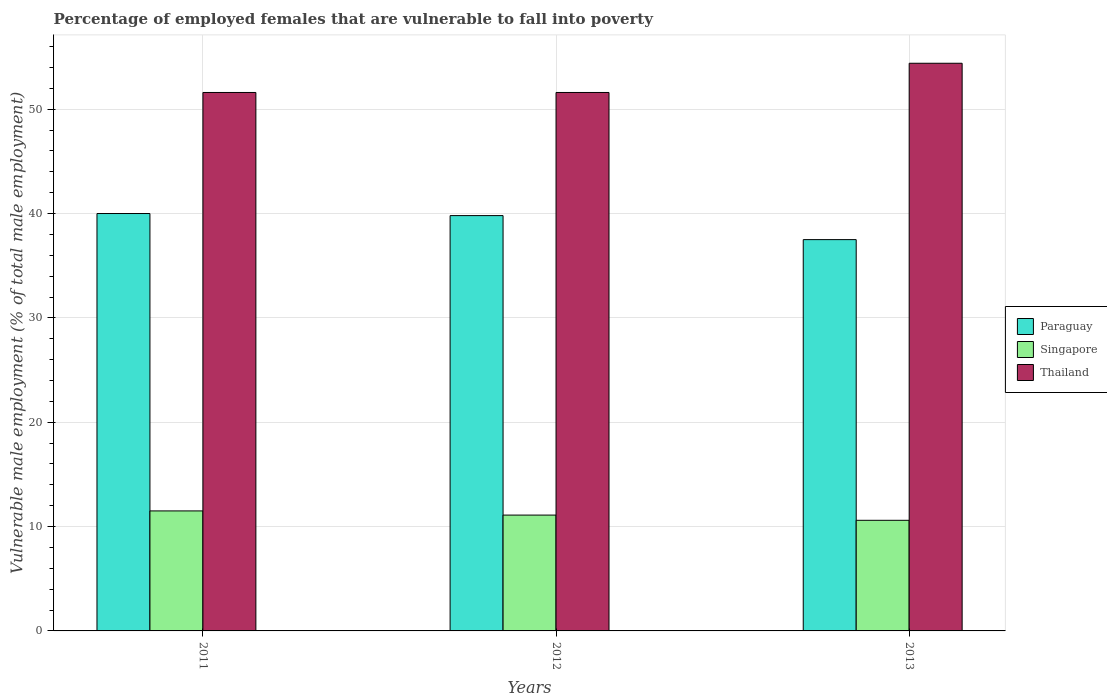How many different coloured bars are there?
Keep it short and to the point. 3. How many bars are there on the 1st tick from the left?
Provide a succinct answer. 3. How many bars are there on the 1st tick from the right?
Keep it short and to the point. 3. In how many cases, is the number of bars for a given year not equal to the number of legend labels?
Give a very brief answer. 0. What is the percentage of employed females who are vulnerable to fall into poverty in Thailand in 2011?
Provide a succinct answer. 51.6. Across all years, what is the maximum percentage of employed females who are vulnerable to fall into poverty in Thailand?
Give a very brief answer. 54.4. Across all years, what is the minimum percentage of employed females who are vulnerable to fall into poverty in Singapore?
Make the answer very short. 10.6. In which year was the percentage of employed females who are vulnerable to fall into poverty in Singapore maximum?
Provide a short and direct response. 2011. What is the total percentage of employed females who are vulnerable to fall into poverty in Singapore in the graph?
Give a very brief answer. 33.2. What is the difference between the percentage of employed females who are vulnerable to fall into poverty in Paraguay in 2012 and that in 2013?
Your answer should be very brief. 2.3. What is the difference between the percentage of employed females who are vulnerable to fall into poverty in Paraguay in 2011 and the percentage of employed females who are vulnerable to fall into poverty in Singapore in 2013?
Your response must be concise. 29.4. What is the average percentage of employed females who are vulnerable to fall into poverty in Paraguay per year?
Keep it short and to the point. 39.1. In the year 2011, what is the difference between the percentage of employed females who are vulnerable to fall into poverty in Singapore and percentage of employed females who are vulnerable to fall into poverty in Thailand?
Offer a very short reply. -40.1. In how many years, is the percentage of employed females who are vulnerable to fall into poverty in Paraguay greater than 6 %?
Make the answer very short. 3. What is the ratio of the percentage of employed females who are vulnerable to fall into poverty in Thailand in 2011 to that in 2013?
Give a very brief answer. 0.95. What is the difference between the highest and the second highest percentage of employed females who are vulnerable to fall into poverty in Paraguay?
Your response must be concise. 0.2. Is the sum of the percentage of employed females who are vulnerable to fall into poverty in Thailand in 2011 and 2012 greater than the maximum percentage of employed females who are vulnerable to fall into poverty in Paraguay across all years?
Ensure brevity in your answer.  Yes. What does the 3rd bar from the left in 2011 represents?
Offer a terse response. Thailand. What does the 1st bar from the right in 2013 represents?
Your answer should be very brief. Thailand. Is it the case that in every year, the sum of the percentage of employed females who are vulnerable to fall into poverty in Paraguay and percentage of employed females who are vulnerable to fall into poverty in Thailand is greater than the percentage of employed females who are vulnerable to fall into poverty in Singapore?
Provide a short and direct response. Yes. Are all the bars in the graph horizontal?
Ensure brevity in your answer.  No. How many years are there in the graph?
Your answer should be very brief. 3. What is the difference between two consecutive major ticks on the Y-axis?
Keep it short and to the point. 10. Are the values on the major ticks of Y-axis written in scientific E-notation?
Keep it short and to the point. No. Does the graph contain grids?
Offer a terse response. Yes. What is the title of the graph?
Your answer should be compact. Percentage of employed females that are vulnerable to fall into poverty. What is the label or title of the X-axis?
Offer a very short reply. Years. What is the label or title of the Y-axis?
Your answer should be very brief. Vulnerable male employment (% of total male employment). What is the Vulnerable male employment (% of total male employment) of Paraguay in 2011?
Provide a short and direct response. 40. What is the Vulnerable male employment (% of total male employment) of Singapore in 2011?
Your response must be concise. 11.5. What is the Vulnerable male employment (% of total male employment) of Thailand in 2011?
Ensure brevity in your answer.  51.6. What is the Vulnerable male employment (% of total male employment) of Paraguay in 2012?
Your response must be concise. 39.8. What is the Vulnerable male employment (% of total male employment) of Singapore in 2012?
Offer a terse response. 11.1. What is the Vulnerable male employment (% of total male employment) in Thailand in 2012?
Provide a succinct answer. 51.6. What is the Vulnerable male employment (% of total male employment) in Paraguay in 2013?
Offer a terse response. 37.5. What is the Vulnerable male employment (% of total male employment) of Singapore in 2013?
Make the answer very short. 10.6. What is the Vulnerable male employment (% of total male employment) in Thailand in 2013?
Provide a short and direct response. 54.4. Across all years, what is the maximum Vulnerable male employment (% of total male employment) of Thailand?
Keep it short and to the point. 54.4. Across all years, what is the minimum Vulnerable male employment (% of total male employment) in Paraguay?
Give a very brief answer. 37.5. Across all years, what is the minimum Vulnerable male employment (% of total male employment) of Singapore?
Offer a terse response. 10.6. Across all years, what is the minimum Vulnerable male employment (% of total male employment) of Thailand?
Ensure brevity in your answer.  51.6. What is the total Vulnerable male employment (% of total male employment) in Paraguay in the graph?
Your response must be concise. 117.3. What is the total Vulnerable male employment (% of total male employment) in Singapore in the graph?
Provide a succinct answer. 33.2. What is the total Vulnerable male employment (% of total male employment) in Thailand in the graph?
Provide a succinct answer. 157.6. What is the difference between the Vulnerable male employment (% of total male employment) of Paraguay in 2011 and that in 2012?
Ensure brevity in your answer.  0.2. What is the difference between the Vulnerable male employment (% of total male employment) of Thailand in 2011 and that in 2012?
Provide a short and direct response. 0. What is the difference between the Vulnerable male employment (% of total male employment) in Paraguay in 2011 and that in 2013?
Offer a very short reply. 2.5. What is the difference between the Vulnerable male employment (% of total male employment) of Thailand in 2011 and that in 2013?
Give a very brief answer. -2.8. What is the difference between the Vulnerable male employment (% of total male employment) of Paraguay in 2012 and that in 2013?
Keep it short and to the point. 2.3. What is the difference between the Vulnerable male employment (% of total male employment) of Thailand in 2012 and that in 2013?
Ensure brevity in your answer.  -2.8. What is the difference between the Vulnerable male employment (% of total male employment) of Paraguay in 2011 and the Vulnerable male employment (% of total male employment) of Singapore in 2012?
Your answer should be very brief. 28.9. What is the difference between the Vulnerable male employment (% of total male employment) of Paraguay in 2011 and the Vulnerable male employment (% of total male employment) of Thailand in 2012?
Your response must be concise. -11.6. What is the difference between the Vulnerable male employment (% of total male employment) of Singapore in 2011 and the Vulnerable male employment (% of total male employment) of Thailand in 2012?
Provide a short and direct response. -40.1. What is the difference between the Vulnerable male employment (% of total male employment) in Paraguay in 2011 and the Vulnerable male employment (% of total male employment) in Singapore in 2013?
Your answer should be compact. 29.4. What is the difference between the Vulnerable male employment (% of total male employment) in Paraguay in 2011 and the Vulnerable male employment (% of total male employment) in Thailand in 2013?
Offer a terse response. -14.4. What is the difference between the Vulnerable male employment (% of total male employment) of Singapore in 2011 and the Vulnerable male employment (% of total male employment) of Thailand in 2013?
Provide a succinct answer. -42.9. What is the difference between the Vulnerable male employment (% of total male employment) of Paraguay in 2012 and the Vulnerable male employment (% of total male employment) of Singapore in 2013?
Offer a terse response. 29.2. What is the difference between the Vulnerable male employment (% of total male employment) of Paraguay in 2012 and the Vulnerable male employment (% of total male employment) of Thailand in 2013?
Your answer should be compact. -14.6. What is the difference between the Vulnerable male employment (% of total male employment) of Singapore in 2012 and the Vulnerable male employment (% of total male employment) of Thailand in 2013?
Offer a terse response. -43.3. What is the average Vulnerable male employment (% of total male employment) of Paraguay per year?
Your answer should be compact. 39.1. What is the average Vulnerable male employment (% of total male employment) of Singapore per year?
Ensure brevity in your answer.  11.07. What is the average Vulnerable male employment (% of total male employment) in Thailand per year?
Offer a terse response. 52.53. In the year 2011, what is the difference between the Vulnerable male employment (% of total male employment) of Paraguay and Vulnerable male employment (% of total male employment) of Singapore?
Your answer should be compact. 28.5. In the year 2011, what is the difference between the Vulnerable male employment (% of total male employment) of Paraguay and Vulnerable male employment (% of total male employment) of Thailand?
Your response must be concise. -11.6. In the year 2011, what is the difference between the Vulnerable male employment (% of total male employment) in Singapore and Vulnerable male employment (% of total male employment) in Thailand?
Your answer should be compact. -40.1. In the year 2012, what is the difference between the Vulnerable male employment (% of total male employment) in Paraguay and Vulnerable male employment (% of total male employment) in Singapore?
Your answer should be compact. 28.7. In the year 2012, what is the difference between the Vulnerable male employment (% of total male employment) of Singapore and Vulnerable male employment (% of total male employment) of Thailand?
Ensure brevity in your answer.  -40.5. In the year 2013, what is the difference between the Vulnerable male employment (% of total male employment) in Paraguay and Vulnerable male employment (% of total male employment) in Singapore?
Make the answer very short. 26.9. In the year 2013, what is the difference between the Vulnerable male employment (% of total male employment) of Paraguay and Vulnerable male employment (% of total male employment) of Thailand?
Your answer should be compact. -16.9. In the year 2013, what is the difference between the Vulnerable male employment (% of total male employment) in Singapore and Vulnerable male employment (% of total male employment) in Thailand?
Your answer should be compact. -43.8. What is the ratio of the Vulnerable male employment (% of total male employment) in Singapore in 2011 to that in 2012?
Your response must be concise. 1.04. What is the ratio of the Vulnerable male employment (% of total male employment) of Paraguay in 2011 to that in 2013?
Provide a short and direct response. 1.07. What is the ratio of the Vulnerable male employment (% of total male employment) of Singapore in 2011 to that in 2013?
Ensure brevity in your answer.  1.08. What is the ratio of the Vulnerable male employment (% of total male employment) in Thailand in 2011 to that in 2013?
Your answer should be very brief. 0.95. What is the ratio of the Vulnerable male employment (% of total male employment) in Paraguay in 2012 to that in 2013?
Provide a short and direct response. 1.06. What is the ratio of the Vulnerable male employment (% of total male employment) in Singapore in 2012 to that in 2013?
Ensure brevity in your answer.  1.05. What is the ratio of the Vulnerable male employment (% of total male employment) of Thailand in 2012 to that in 2013?
Make the answer very short. 0.95. What is the difference between the highest and the lowest Vulnerable male employment (% of total male employment) in Singapore?
Your answer should be compact. 0.9. 